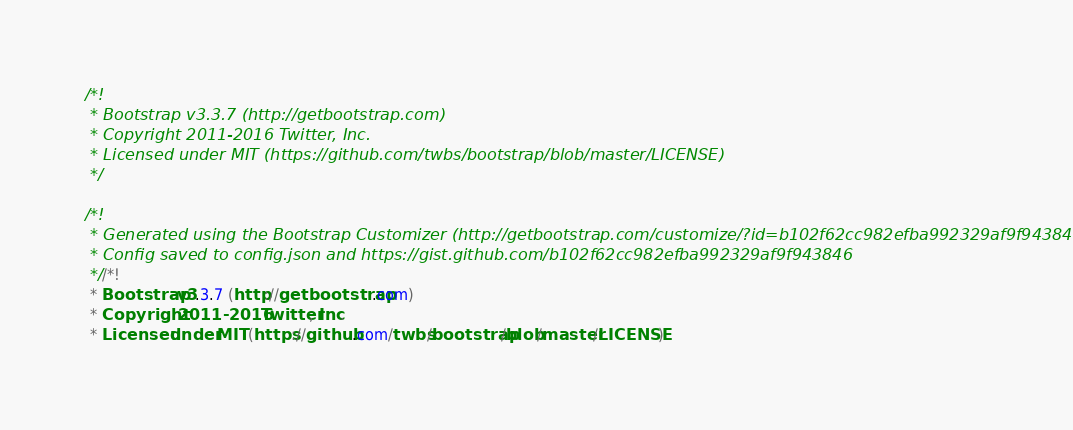<code> <loc_0><loc_0><loc_500><loc_500><_CSS_>/*!
 * Bootstrap v3.3.7 (http://getbootstrap.com)
 * Copyright 2011-2016 Twitter, Inc.
 * Licensed under MIT (https://github.com/twbs/bootstrap/blob/master/LICENSE)
 */

/*!
 * Generated using the Bootstrap Customizer (http://getbootstrap.com/customize/?id=b102f62cc982efba992329af9f943846)
 * Config saved to config.json and https://gist.github.com/b102f62cc982efba992329af9f943846
 *//*!
 * Bootstrap v3.3.7 (http://getbootstrap.com)
 * Copyright 2011-2016 Twitter, Inc.
 * Licensed under MIT (https://github.com/twbs/bootstrap/blob/master/LICENSE)</code> 